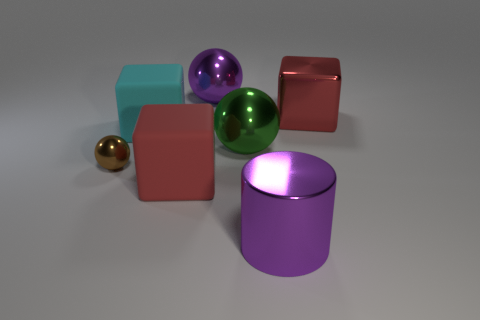Is the shape of the purple metallic object behind the large red metal cube the same as the big purple object to the right of the large purple metal ball?
Your response must be concise. No. There is a object that is the same color as the metallic cylinder; what is its material?
Your response must be concise. Metal. Are any balls visible?
Offer a terse response. Yes. There is a green thing that is the same shape as the brown thing; what is its material?
Keep it short and to the point. Metal. Are there any brown metallic things on the right side of the green ball?
Your answer should be compact. No. Does the big purple thing on the right side of the large purple metal sphere have the same material as the cyan object?
Offer a very short reply. No. Is there a big ball of the same color as the tiny shiny object?
Give a very brief answer. No. What is the shape of the large cyan object?
Give a very brief answer. Cube. There is a sphere in front of the big ball in front of the big red metal block; what color is it?
Your response must be concise. Brown. There is a purple thing behind the large red matte thing; what size is it?
Give a very brief answer. Large. 